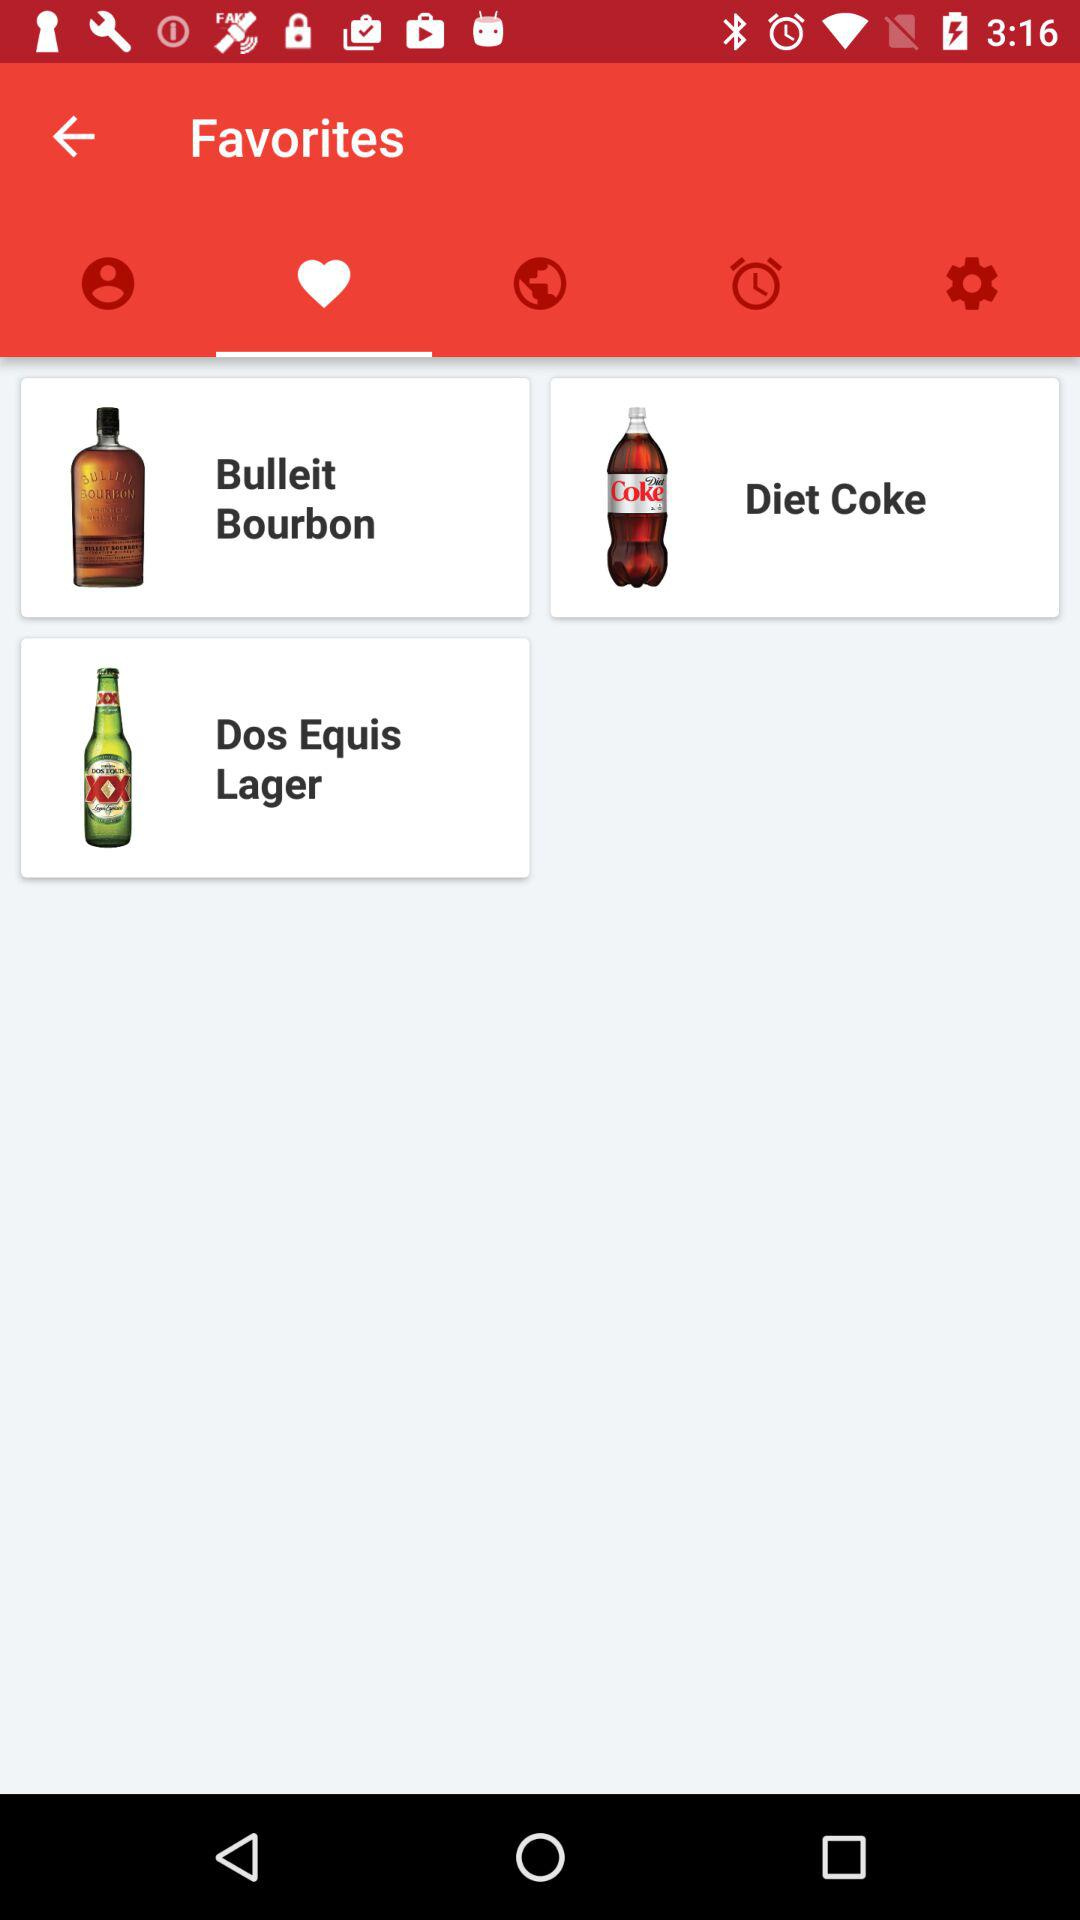Which tab is selected?
Answer the question using a single word or phrase. The selected tab is "Favorites", 